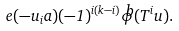Convert formula to latex. <formula><loc_0><loc_0><loc_500><loc_500>e ( - u _ { i } a ) ( - 1 ) ^ { i ( k - i ) } \widehat { \phi } ( T ^ { i } u ) .</formula> 